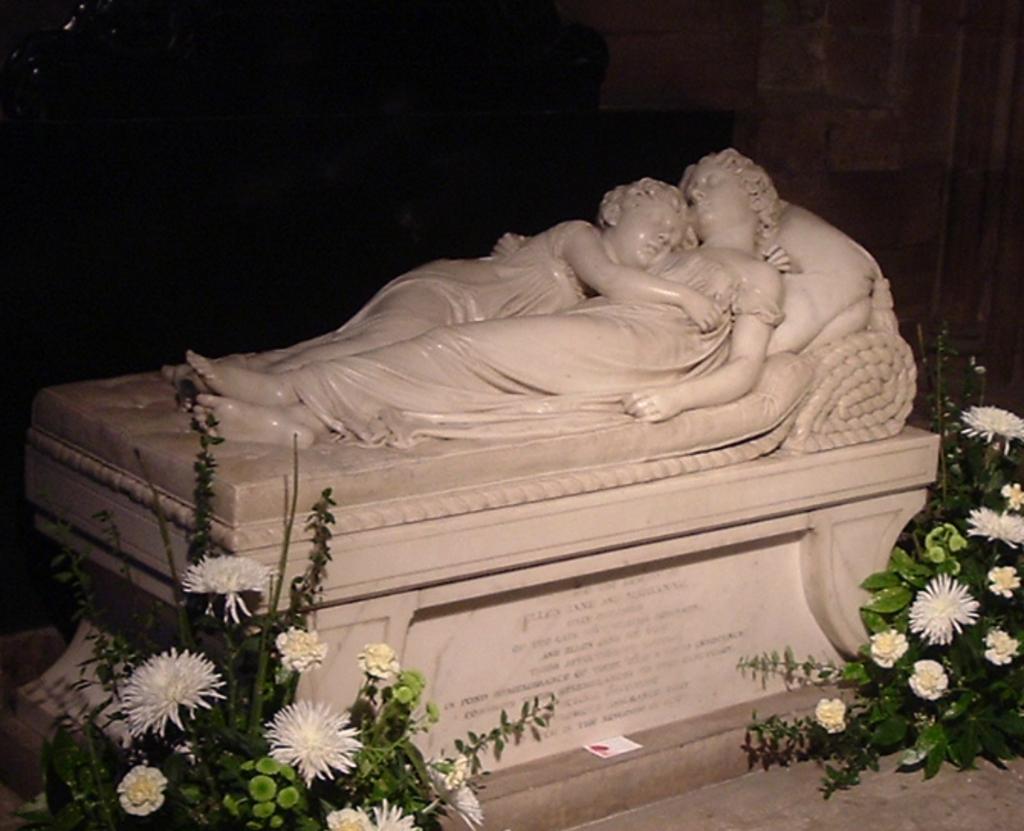Please provide a concise description of this image. In the image there is a pedestal with statues of persons lying. And also there are plants with flowers and leaves. And there is a dark background. 